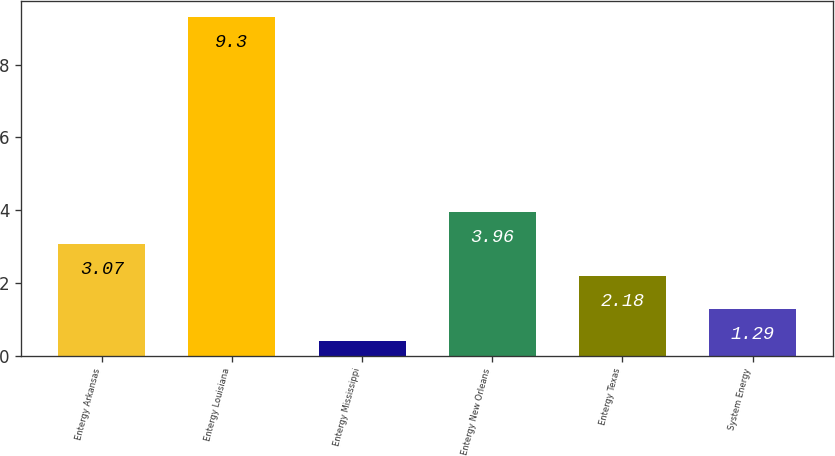Convert chart to OTSL. <chart><loc_0><loc_0><loc_500><loc_500><bar_chart><fcel>Entergy Arkansas<fcel>Entergy Louisiana<fcel>Entergy Mississippi<fcel>Entergy New Orleans<fcel>Entergy Texas<fcel>System Energy<nl><fcel>3.07<fcel>9.3<fcel>0.4<fcel>3.96<fcel>2.18<fcel>1.29<nl></chart> 